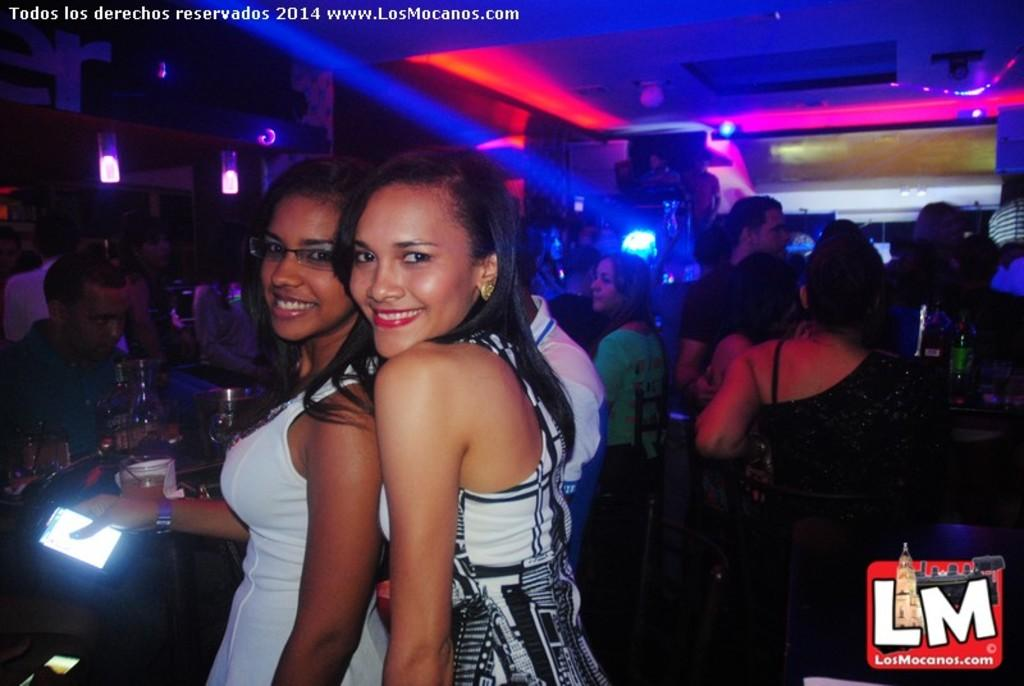Who or what can be seen in the image? There are people in the image. What is located on the left side of the image? There are objects on a table on the left side of the image. What can be seen at the top of the image? There are lights visible at the top of the image. What type of mask is being worn by the people in the image? There is no mention of a mask in the image, so it cannot be determined if anyone is wearing a mask. 